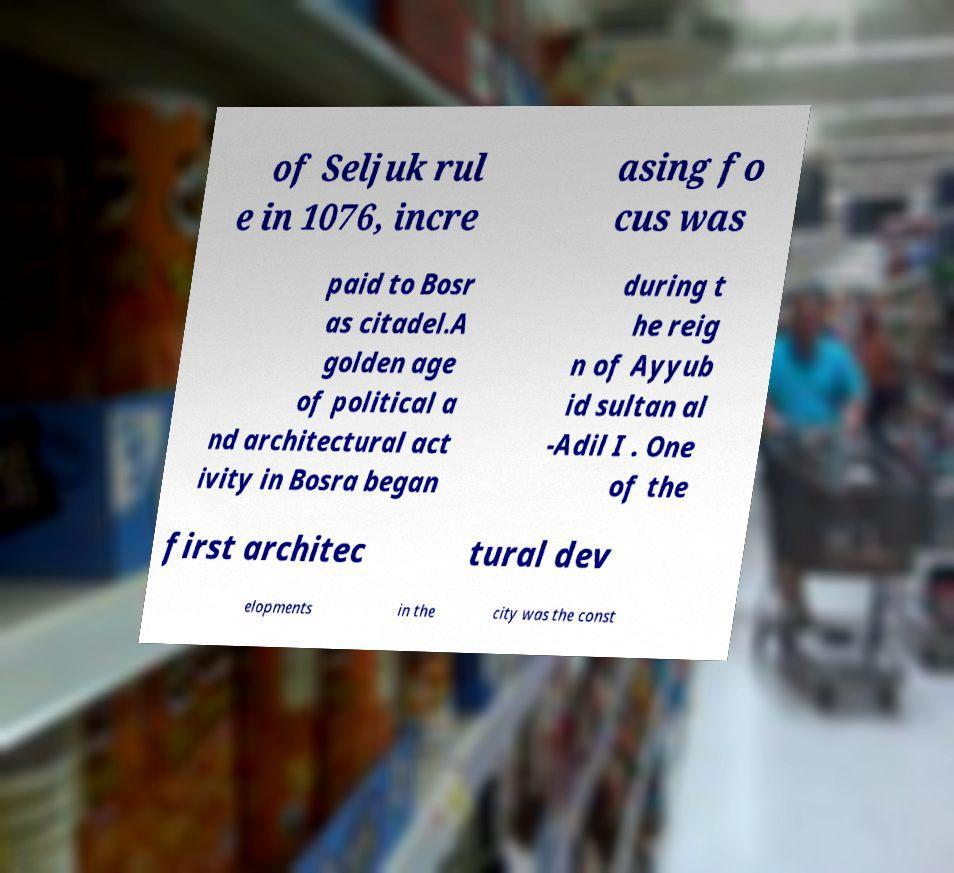Can you accurately transcribe the text from the provided image for me? of Seljuk rul e in 1076, incre asing fo cus was paid to Bosr as citadel.A golden age of political a nd architectural act ivity in Bosra began during t he reig n of Ayyub id sultan al -Adil I . One of the first architec tural dev elopments in the city was the const 